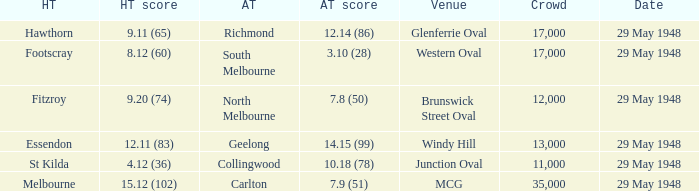In the match where footscray was the home team, how much did they score? 8.12 (60). 